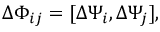Convert formula to latex. <formula><loc_0><loc_0><loc_500><loc_500>\Delta \Phi _ { i j } = [ \Delta \Psi _ { i } , \Delta \Psi _ { j } ] ,</formula> 